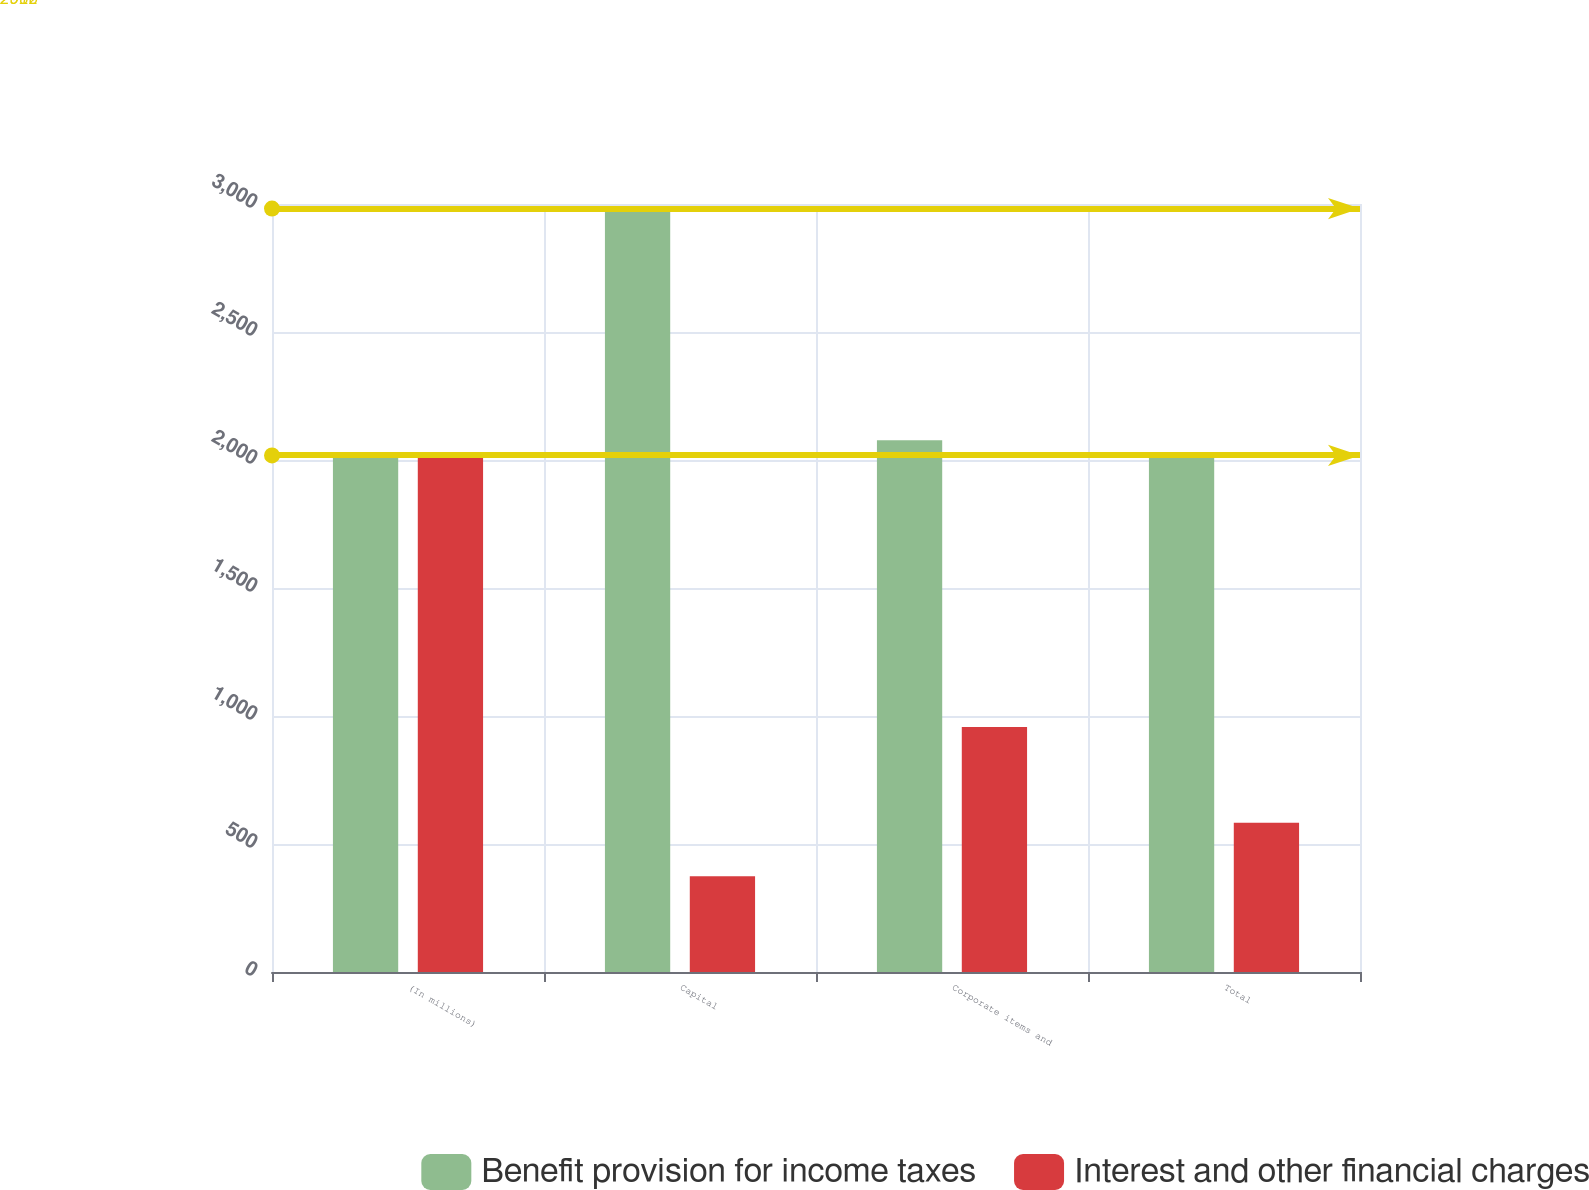<chart> <loc_0><loc_0><loc_500><loc_500><stacked_bar_chart><ecel><fcel>(In millions)<fcel>Capital<fcel>Corporate items and<fcel>Total<nl><fcel>Benefit provision for income taxes<fcel>2018<fcel>2982<fcel>2077<fcel>2018<nl><fcel>Interest and other financial charges<fcel>2018<fcel>374<fcel>957<fcel>583<nl></chart> 